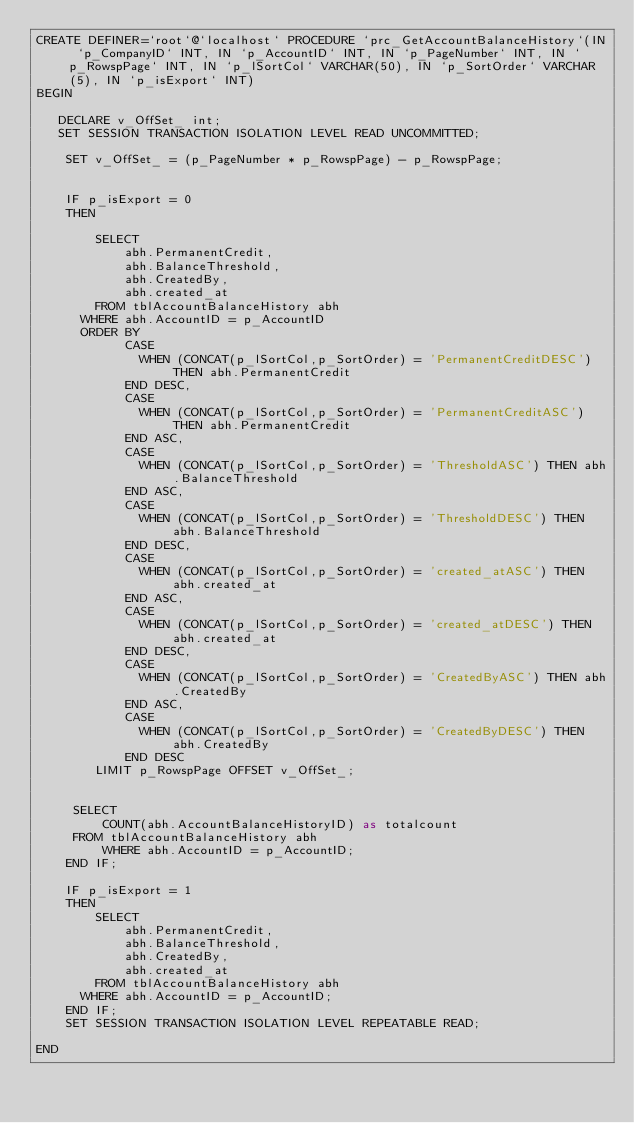Convert code to text. <code><loc_0><loc_0><loc_500><loc_500><_SQL_>CREATE DEFINER=`root`@`localhost` PROCEDURE `prc_GetAccountBalanceHistory`(IN `p_CompanyID` INT, IN `p_AccountID` INT, IN `p_PageNumber` INT, IN `p_RowspPage` INT, IN `p_lSortCol` VARCHAR(50), IN `p_SortOrder` VARCHAR(5), IN `p_isExport` INT)
BEGIN

   DECLARE v_OffSet_ int;
   SET SESSION TRANSACTION ISOLATION LEVEL READ UNCOMMITTED;
	 
	SET v_OffSet_ = (p_PageNumber * p_RowspPage) - p_RowspPage;
	
	
    IF p_isExport = 0
    THEN
         
		SELECT
			abh.PermanentCredit,
			abh.BalanceThreshold,
			abh.CreatedBy,
			abh.created_at
		FROM tblAccountBalanceHistory abh
      WHERE abh.AccountID = p_AccountID
      ORDER BY                
			CASE
			  WHEN (CONCAT(p_lSortCol,p_SortOrder) = 'PermanentCreditDESC') THEN abh.PermanentCredit
			END DESC,
			CASE
			  WHEN (CONCAT(p_lSortCol,p_SortOrder) = 'PermanentCreditASC') THEN abh.PermanentCredit
			END ASC,				
			CASE
			  WHEN (CONCAT(p_lSortCol,p_SortOrder) = 'ThresholdASC') THEN abh.BalanceThreshold
			END ASC,
			CASE
			  WHEN (CONCAT(p_lSortCol,p_SortOrder) = 'ThresholdDESC') THEN abh.BalanceThreshold
			END DESC,
			CASE
			  WHEN (CONCAT(p_lSortCol,p_SortOrder) = 'created_atASC') THEN abh.created_at
			END ASC,
			CASE
			  WHEN (CONCAT(p_lSortCol,p_SortOrder) = 'created_atDESC') THEN abh.created_at
			END DESC,
			CASE
			  WHEN (CONCAT(p_lSortCol,p_SortOrder) = 'CreatedByASC') THEN abh.CreatedBy
			END ASC,
			CASE
			  WHEN (CONCAT(p_lSortCol,p_SortOrder) = 'CreatedByDESC') THEN abh.CreatedBy
			END DESC
		LIMIT p_RowspPage OFFSET v_OffSet_;


     SELECT
         COUNT(abh.AccountBalanceHistoryID) as totalcount
     FROM tblAccountBalanceHistory abh
         WHERE abh.AccountID = p_AccountID;
    END IF;

    IF p_isExport = 1
    THEN
        SELECT
			abh.PermanentCredit,
			abh.BalanceThreshold,
			abh.CreatedBy,
			abh.created_at
		FROM tblAccountBalanceHistory abh
      WHERE abh.AccountID = p_AccountID;
    END IF;
    SET SESSION TRANSACTION ISOLATION LEVEL REPEATABLE READ;

END</code> 